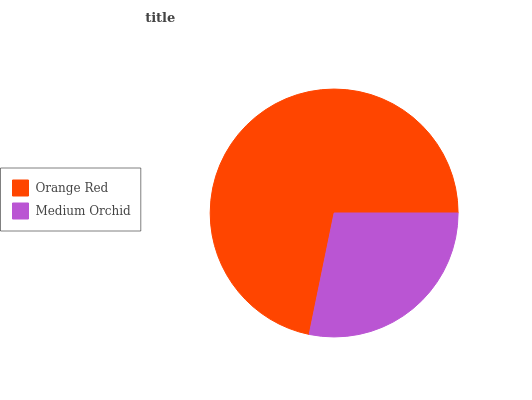Is Medium Orchid the minimum?
Answer yes or no. Yes. Is Orange Red the maximum?
Answer yes or no. Yes. Is Medium Orchid the maximum?
Answer yes or no. No. Is Orange Red greater than Medium Orchid?
Answer yes or no. Yes. Is Medium Orchid less than Orange Red?
Answer yes or no. Yes. Is Medium Orchid greater than Orange Red?
Answer yes or no. No. Is Orange Red less than Medium Orchid?
Answer yes or no. No. Is Orange Red the high median?
Answer yes or no. Yes. Is Medium Orchid the low median?
Answer yes or no. Yes. Is Medium Orchid the high median?
Answer yes or no. No. Is Orange Red the low median?
Answer yes or no. No. 